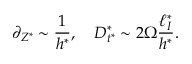Convert formula to latex. <formula><loc_0><loc_0><loc_500><loc_500>\partial _ { Z ^ { * } } \sim \frac { 1 } { h ^ { * } } , \quad D _ { t ^ { * } } ^ { * } \sim 2 \Omega \frac { \ell _ { I } ^ { * } } { h ^ { * } } .</formula> 